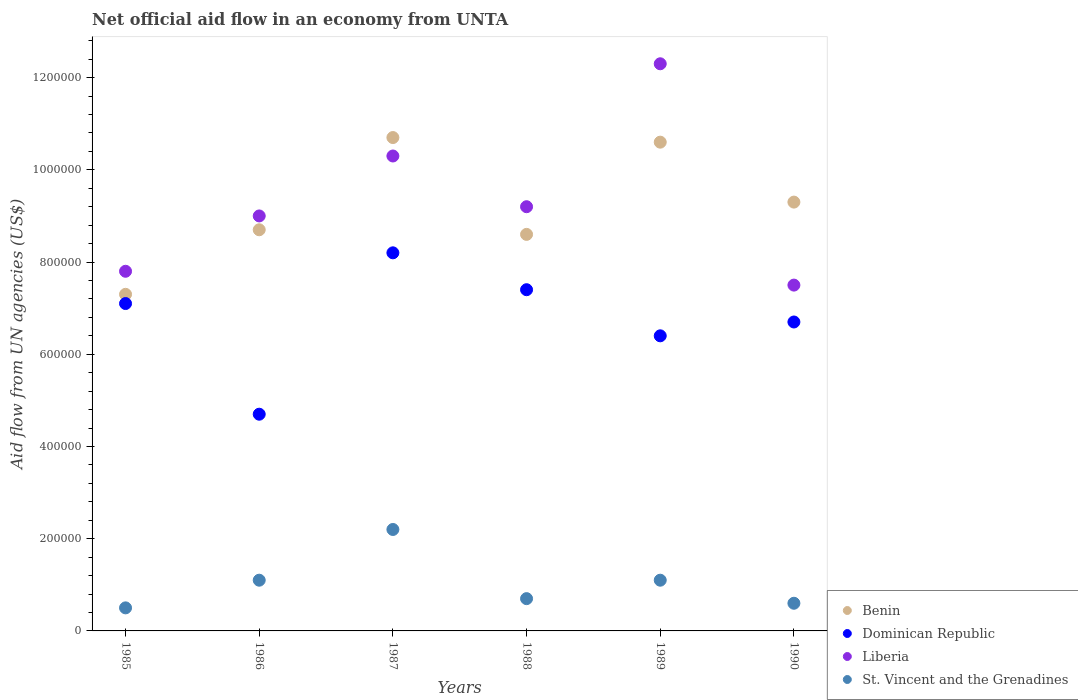How many different coloured dotlines are there?
Offer a very short reply. 4. What is the net official aid flow in Dominican Republic in 1988?
Ensure brevity in your answer.  7.40e+05. Across all years, what is the maximum net official aid flow in St. Vincent and the Grenadines?
Ensure brevity in your answer.  2.20e+05. Across all years, what is the minimum net official aid flow in Benin?
Your answer should be compact. 7.30e+05. In which year was the net official aid flow in St. Vincent and the Grenadines maximum?
Keep it short and to the point. 1987. In which year was the net official aid flow in Dominican Republic minimum?
Your answer should be compact. 1986. What is the total net official aid flow in Dominican Republic in the graph?
Make the answer very short. 4.05e+06. What is the difference between the net official aid flow in St. Vincent and the Grenadines in 1988 and that in 1990?
Your answer should be compact. 10000. What is the difference between the net official aid flow in Liberia in 1988 and the net official aid flow in St. Vincent and the Grenadines in 1986?
Offer a very short reply. 8.10e+05. What is the average net official aid flow in Benin per year?
Offer a very short reply. 9.20e+05. In how many years, is the net official aid flow in Dominican Republic greater than 520000 US$?
Your answer should be very brief. 5. What is the ratio of the net official aid flow in St. Vincent and the Grenadines in 1985 to that in 1988?
Offer a terse response. 0.71. Is the net official aid flow in St. Vincent and the Grenadines in 1985 less than that in 1989?
Offer a terse response. Yes. Is the difference between the net official aid flow in Benin in 1987 and 1989 greater than the difference between the net official aid flow in Liberia in 1987 and 1989?
Offer a very short reply. Yes. What is the difference between the highest and the second highest net official aid flow in Dominican Republic?
Keep it short and to the point. 8.00e+04. In how many years, is the net official aid flow in St. Vincent and the Grenadines greater than the average net official aid flow in St. Vincent and the Grenadines taken over all years?
Provide a short and direct response. 3. Is it the case that in every year, the sum of the net official aid flow in St. Vincent and the Grenadines and net official aid flow in Liberia  is greater than the net official aid flow in Dominican Republic?
Your response must be concise. Yes. What is the difference between two consecutive major ticks on the Y-axis?
Ensure brevity in your answer.  2.00e+05. Does the graph contain any zero values?
Give a very brief answer. No. What is the title of the graph?
Your response must be concise. Net official aid flow in an economy from UNTA. What is the label or title of the X-axis?
Give a very brief answer. Years. What is the label or title of the Y-axis?
Offer a terse response. Aid flow from UN agencies (US$). What is the Aid flow from UN agencies (US$) of Benin in 1985?
Provide a short and direct response. 7.30e+05. What is the Aid flow from UN agencies (US$) in Dominican Republic in 1985?
Provide a short and direct response. 7.10e+05. What is the Aid flow from UN agencies (US$) in Liberia in 1985?
Ensure brevity in your answer.  7.80e+05. What is the Aid flow from UN agencies (US$) of Benin in 1986?
Offer a very short reply. 8.70e+05. What is the Aid flow from UN agencies (US$) in Dominican Republic in 1986?
Make the answer very short. 4.70e+05. What is the Aid flow from UN agencies (US$) in Benin in 1987?
Give a very brief answer. 1.07e+06. What is the Aid flow from UN agencies (US$) in Dominican Republic in 1987?
Provide a succinct answer. 8.20e+05. What is the Aid flow from UN agencies (US$) of Liberia in 1987?
Offer a very short reply. 1.03e+06. What is the Aid flow from UN agencies (US$) of Benin in 1988?
Offer a terse response. 8.60e+05. What is the Aid flow from UN agencies (US$) in Dominican Republic in 1988?
Make the answer very short. 7.40e+05. What is the Aid flow from UN agencies (US$) in Liberia in 1988?
Your answer should be compact. 9.20e+05. What is the Aid flow from UN agencies (US$) in Benin in 1989?
Offer a very short reply. 1.06e+06. What is the Aid flow from UN agencies (US$) of Dominican Republic in 1989?
Ensure brevity in your answer.  6.40e+05. What is the Aid flow from UN agencies (US$) of Liberia in 1989?
Keep it short and to the point. 1.23e+06. What is the Aid flow from UN agencies (US$) of St. Vincent and the Grenadines in 1989?
Offer a terse response. 1.10e+05. What is the Aid flow from UN agencies (US$) of Benin in 1990?
Keep it short and to the point. 9.30e+05. What is the Aid flow from UN agencies (US$) in Dominican Republic in 1990?
Keep it short and to the point. 6.70e+05. What is the Aid flow from UN agencies (US$) of Liberia in 1990?
Provide a short and direct response. 7.50e+05. Across all years, what is the maximum Aid flow from UN agencies (US$) in Benin?
Your answer should be compact. 1.07e+06. Across all years, what is the maximum Aid flow from UN agencies (US$) in Dominican Republic?
Your response must be concise. 8.20e+05. Across all years, what is the maximum Aid flow from UN agencies (US$) of Liberia?
Your answer should be very brief. 1.23e+06. Across all years, what is the maximum Aid flow from UN agencies (US$) of St. Vincent and the Grenadines?
Your answer should be very brief. 2.20e+05. Across all years, what is the minimum Aid flow from UN agencies (US$) of Benin?
Give a very brief answer. 7.30e+05. Across all years, what is the minimum Aid flow from UN agencies (US$) of Dominican Republic?
Give a very brief answer. 4.70e+05. Across all years, what is the minimum Aid flow from UN agencies (US$) in Liberia?
Give a very brief answer. 7.50e+05. Across all years, what is the minimum Aid flow from UN agencies (US$) of St. Vincent and the Grenadines?
Offer a terse response. 5.00e+04. What is the total Aid flow from UN agencies (US$) in Benin in the graph?
Your answer should be compact. 5.52e+06. What is the total Aid flow from UN agencies (US$) in Dominican Republic in the graph?
Make the answer very short. 4.05e+06. What is the total Aid flow from UN agencies (US$) in Liberia in the graph?
Your response must be concise. 5.61e+06. What is the total Aid flow from UN agencies (US$) of St. Vincent and the Grenadines in the graph?
Give a very brief answer. 6.20e+05. What is the difference between the Aid flow from UN agencies (US$) in Dominican Republic in 1985 and that in 1986?
Your response must be concise. 2.40e+05. What is the difference between the Aid flow from UN agencies (US$) in Liberia in 1985 and that in 1986?
Provide a succinct answer. -1.20e+05. What is the difference between the Aid flow from UN agencies (US$) in St. Vincent and the Grenadines in 1985 and that in 1986?
Give a very brief answer. -6.00e+04. What is the difference between the Aid flow from UN agencies (US$) in Dominican Republic in 1985 and that in 1988?
Provide a succinct answer. -3.00e+04. What is the difference between the Aid flow from UN agencies (US$) of Liberia in 1985 and that in 1988?
Keep it short and to the point. -1.40e+05. What is the difference between the Aid flow from UN agencies (US$) in St. Vincent and the Grenadines in 1985 and that in 1988?
Provide a short and direct response. -2.00e+04. What is the difference between the Aid flow from UN agencies (US$) in Benin in 1985 and that in 1989?
Your answer should be compact. -3.30e+05. What is the difference between the Aid flow from UN agencies (US$) in Dominican Republic in 1985 and that in 1989?
Your answer should be very brief. 7.00e+04. What is the difference between the Aid flow from UN agencies (US$) in Liberia in 1985 and that in 1989?
Make the answer very short. -4.50e+05. What is the difference between the Aid flow from UN agencies (US$) in St. Vincent and the Grenadines in 1985 and that in 1989?
Make the answer very short. -6.00e+04. What is the difference between the Aid flow from UN agencies (US$) in Dominican Republic in 1985 and that in 1990?
Your response must be concise. 4.00e+04. What is the difference between the Aid flow from UN agencies (US$) in St. Vincent and the Grenadines in 1985 and that in 1990?
Give a very brief answer. -10000. What is the difference between the Aid flow from UN agencies (US$) of Dominican Republic in 1986 and that in 1987?
Your answer should be very brief. -3.50e+05. What is the difference between the Aid flow from UN agencies (US$) of Benin in 1986 and that in 1988?
Provide a succinct answer. 10000. What is the difference between the Aid flow from UN agencies (US$) in Dominican Republic in 1986 and that in 1988?
Your answer should be very brief. -2.70e+05. What is the difference between the Aid flow from UN agencies (US$) of St. Vincent and the Grenadines in 1986 and that in 1988?
Your response must be concise. 4.00e+04. What is the difference between the Aid flow from UN agencies (US$) in Benin in 1986 and that in 1989?
Provide a succinct answer. -1.90e+05. What is the difference between the Aid flow from UN agencies (US$) in Dominican Republic in 1986 and that in 1989?
Provide a succinct answer. -1.70e+05. What is the difference between the Aid flow from UN agencies (US$) of Liberia in 1986 and that in 1989?
Offer a very short reply. -3.30e+05. What is the difference between the Aid flow from UN agencies (US$) of St. Vincent and the Grenadines in 1986 and that in 1989?
Offer a very short reply. 0. What is the difference between the Aid flow from UN agencies (US$) of Dominican Republic in 1986 and that in 1990?
Give a very brief answer. -2.00e+05. What is the difference between the Aid flow from UN agencies (US$) of St. Vincent and the Grenadines in 1986 and that in 1990?
Your response must be concise. 5.00e+04. What is the difference between the Aid flow from UN agencies (US$) of Benin in 1987 and that in 1988?
Offer a terse response. 2.10e+05. What is the difference between the Aid flow from UN agencies (US$) of St. Vincent and the Grenadines in 1987 and that in 1988?
Offer a very short reply. 1.50e+05. What is the difference between the Aid flow from UN agencies (US$) of Benin in 1987 and that in 1989?
Your answer should be very brief. 10000. What is the difference between the Aid flow from UN agencies (US$) of Dominican Republic in 1987 and that in 1989?
Your answer should be very brief. 1.80e+05. What is the difference between the Aid flow from UN agencies (US$) of St. Vincent and the Grenadines in 1987 and that in 1989?
Your answer should be compact. 1.10e+05. What is the difference between the Aid flow from UN agencies (US$) in Liberia in 1987 and that in 1990?
Keep it short and to the point. 2.80e+05. What is the difference between the Aid flow from UN agencies (US$) in Benin in 1988 and that in 1989?
Your answer should be compact. -2.00e+05. What is the difference between the Aid flow from UN agencies (US$) in Liberia in 1988 and that in 1989?
Give a very brief answer. -3.10e+05. What is the difference between the Aid flow from UN agencies (US$) in St. Vincent and the Grenadines in 1988 and that in 1989?
Provide a succinct answer. -4.00e+04. What is the difference between the Aid flow from UN agencies (US$) in Benin in 1988 and that in 1990?
Provide a succinct answer. -7.00e+04. What is the difference between the Aid flow from UN agencies (US$) of Dominican Republic in 1988 and that in 1990?
Keep it short and to the point. 7.00e+04. What is the difference between the Aid flow from UN agencies (US$) in Liberia in 1988 and that in 1990?
Ensure brevity in your answer.  1.70e+05. What is the difference between the Aid flow from UN agencies (US$) of St. Vincent and the Grenadines in 1988 and that in 1990?
Offer a terse response. 10000. What is the difference between the Aid flow from UN agencies (US$) in Benin in 1989 and that in 1990?
Provide a short and direct response. 1.30e+05. What is the difference between the Aid flow from UN agencies (US$) of Dominican Republic in 1989 and that in 1990?
Make the answer very short. -3.00e+04. What is the difference between the Aid flow from UN agencies (US$) of Liberia in 1989 and that in 1990?
Your answer should be very brief. 4.80e+05. What is the difference between the Aid flow from UN agencies (US$) of Benin in 1985 and the Aid flow from UN agencies (US$) of Dominican Republic in 1986?
Your answer should be very brief. 2.60e+05. What is the difference between the Aid flow from UN agencies (US$) in Benin in 1985 and the Aid flow from UN agencies (US$) in St. Vincent and the Grenadines in 1986?
Offer a very short reply. 6.20e+05. What is the difference between the Aid flow from UN agencies (US$) in Dominican Republic in 1985 and the Aid flow from UN agencies (US$) in St. Vincent and the Grenadines in 1986?
Give a very brief answer. 6.00e+05. What is the difference between the Aid flow from UN agencies (US$) of Liberia in 1985 and the Aid flow from UN agencies (US$) of St. Vincent and the Grenadines in 1986?
Your response must be concise. 6.70e+05. What is the difference between the Aid flow from UN agencies (US$) in Benin in 1985 and the Aid flow from UN agencies (US$) in Dominican Republic in 1987?
Provide a succinct answer. -9.00e+04. What is the difference between the Aid flow from UN agencies (US$) in Benin in 1985 and the Aid flow from UN agencies (US$) in St. Vincent and the Grenadines in 1987?
Your answer should be compact. 5.10e+05. What is the difference between the Aid flow from UN agencies (US$) in Dominican Republic in 1985 and the Aid flow from UN agencies (US$) in Liberia in 1987?
Offer a very short reply. -3.20e+05. What is the difference between the Aid flow from UN agencies (US$) in Dominican Republic in 1985 and the Aid flow from UN agencies (US$) in St. Vincent and the Grenadines in 1987?
Your answer should be compact. 4.90e+05. What is the difference between the Aid flow from UN agencies (US$) of Liberia in 1985 and the Aid flow from UN agencies (US$) of St. Vincent and the Grenadines in 1987?
Offer a very short reply. 5.60e+05. What is the difference between the Aid flow from UN agencies (US$) of Benin in 1985 and the Aid flow from UN agencies (US$) of Liberia in 1988?
Your answer should be compact. -1.90e+05. What is the difference between the Aid flow from UN agencies (US$) of Dominican Republic in 1985 and the Aid flow from UN agencies (US$) of Liberia in 1988?
Give a very brief answer. -2.10e+05. What is the difference between the Aid flow from UN agencies (US$) in Dominican Republic in 1985 and the Aid flow from UN agencies (US$) in St. Vincent and the Grenadines in 1988?
Offer a terse response. 6.40e+05. What is the difference between the Aid flow from UN agencies (US$) of Liberia in 1985 and the Aid flow from UN agencies (US$) of St. Vincent and the Grenadines in 1988?
Your response must be concise. 7.10e+05. What is the difference between the Aid flow from UN agencies (US$) in Benin in 1985 and the Aid flow from UN agencies (US$) in Dominican Republic in 1989?
Your answer should be very brief. 9.00e+04. What is the difference between the Aid flow from UN agencies (US$) in Benin in 1985 and the Aid flow from UN agencies (US$) in Liberia in 1989?
Offer a very short reply. -5.00e+05. What is the difference between the Aid flow from UN agencies (US$) of Benin in 1985 and the Aid flow from UN agencies (US$) of St. Vincent and the Grenadines in 1989?
Provide a short and direct response. 6.20e+05. What is the difference between the Aid flow from UN agencies (US$) of Dominican Republic in 1985 and the Aid flow from UN agencies (US$) of Liberia in 1989?
Offer a very short reply. -5.20e+05. What is the difference between the Aid flow from UN agencies (US$) of Liberia in 1985 and the Aid flow from UN agencies (US$) of St. Vincent and the Grenadines in 1989?
Your response must be concise. 6.70e+05. What is the difference between the Aid flow from UN agencies (US$) in Benin in 1985 and the Aid flow from UN agencies (US$) in St. Vincent and the Grenadines in 1990?
Your answer should be very brief. 6.70e+05. What is the difference between the Aid flow from UN agencies (US$) in Dominican Republic in 1985 and the Aid flow from UN agencies (US$) in St. Vincent and the Grenadines in 1990?
Offer a very short reply. 6.50e+05. What is the difference between the Aid flow from UN agencies (US$) in Liberia in 1985 and the Aid flow from UN agencies (US$) in St. Vincent and the Grenadines in 1990?
Your answer should be compact. 7.20e+05. What is the difference between the Aid flow from UN agencies (US$) of Benin in 1986 and the Aid flow from UN agencies (US$) of Dominican Republic in 1987?
Make the answer very short. 5.00e+04. What is the difference between the Aid flow from UN agencies (US$) in Benin in 1986 and the Aid flow from UN agencies (US$) in Liberia in 1987?
Your answer should be very brief. -1.60e+05. What is the difference between the Aid flow from UN agencies (US$) in Benin in 1986 and the Aid flow from UN agencies (US$) in St. Vincent and the Grenadines in 1987?
Offer a very short reply. 6.50e+05. What is the difference between the Aid flow from UN agencies (US$) of Dominican Republic in 1986 and the Aid flow from UN agencies (US$) of Liberia in 1987?
Make the answer very short. -5.60e+05. What is the difference between the Aid flow from UN agencies (US$) in Liberia in 1986 and the Aid flow from UN agencies (US$) in St. Vincent and the Grenadines in 1987?
Your answer should be compact. 6.80e+05. What is the difference between the Aid flow from UN agencies (US$) of Benin in 1986 and the Aid flow from UN agencies (US$) of Dominican Republic in 1988?
Your answer should be compact. 1.30e+05. What is the difference between the Aid flow from UN agencies (US$) of Benin in 1986 and the Aid flow from UN agencies (US$) of Liberia in 1988?
Make the answer very short. -5.00e+04. What is the difference between the Aid flow from UN agencies (US$) of Benin in 1986 and the Aid flow from UN agencies (US$) of St. Vincent and the Grenadines in 1988?
Your answer should be very brief. 8.00e+05. What is the difference between the Aid flow from UN agencies (US$) of Dominican Republic in 1986 and the Aid flow from UN agencies (US$) of Liberia in 1988?
Make the answer very short. -4.50e+05. What is the difference between the Aid flow from UN agencies (US$) in Liberia in 1986 and the Aid flow from UN agencies (US$) in St. Vincent and the Grenadines in 1988?
Your answer should be compact. 8.30e+05. What is the difference between the Aid flow from UN agencies (US$) of Benin in 1986 and the Aid flow from UN agencies (US$) of Dominican Republic in 1989?
Provide a short and direct response. 2.30e+05. What is the difference between the Aid flow from UN agencies (US$) of Benin in 1986 and the Aid flow from UN agencies (US$) of Liberia in 1989?
Provide a succinct answer. -3.60e+05. What is the difference between the Aid flow from UN agencies (US$) in Benin in 1986 and the Aid flow from UN agencies (US$) in St. Vincent and the Grenadines in 1989?
Make the answer very short. 7.60e+05. What is the difference between the Aid flow from UN agencies (US$) in Dominican Republic in 1986 and the Aid flow from UN agencies (US$) in Liberia in 1989?
Give a very brief answer. -7.60e+05. What is the difference between the Aid flow from UN agencies (US$) of Dominican Republic in 1986 and the Aid flow from UN agencies (US$) of St. Vincent and the Grenadines in 1989?
Offer a very short reply. 3.60e+05. What is the difference between the Aid flow from UN agencies (US$) of Liberia in 1986 and the Aid flow from UN agencies (US$) of St. Vincent and the Grenadines in 1989?
Offer a very short reply. 7.90e+05. What is the difference between the Aid flow from UN agencies (US$) in Benin in 1986 and the Aid flow from UN agencies (US$) in St. Vincent and the Grenadines in 1990?
Your response must be concise. 8.10e+05. What is the difference between the Aid flow from UN agencies (US$) in Dominican Republic in 1986 and the Aid flow from UN agencies (US$) in Liberia in 1990?
Ensure brevity in your answer.  -2.80e+05. What is the difference between the Aid flow from UN agencies (US$) of Dominican Republic in 1986 and the Aid flow from UN agencies (US$) of St. Vincent and the Grenadines in 1990?
Give a very brief answer. 4.10e+05. What is the difference between the Aid flow from UN agencies (US$) in Liberia in 1986 and the Aid flow from UN agencies (US$) in St. Vincent and the Grenadines in 1990?
Your response must be concise. 8.40e+05. What is the difference between the Aid flow from UN agencies (US$) of Benin in 1987 and the Aid flow from UN agencies (US$) of Liberia in 1988?
Provide a short and direct response. 1.50e+05. What is the difference between the Aid flow from UN agencies (US$) of Dominican Republic in 1987 and the Aid flow from UN agencies (US$) of St. Vincent and the Grenadines in 1988?
Keep it short and to the point. 7.50e+05. What is the difference between the Aid flow from UN agencies (US$) in Liberia in 1987 and the Aid flow from UN agencies (US$) in St. Vincent and the Grenadines in 1988?
Ensure brevity in your answer.  9.60e+05. What is the difference between the Aid flow from UN agencies (US$) in Benin in 1987 and the Aid flow from UN agencies (US$) in Liberia in 1989?
Provide a short and direct response. -1.60e+05. What is the difference between the Aid flow from UN agencies (US$) of Benin in 1987 and the Aid flow from UN agencies (US$) of St. Vincent and the Grenadines in 1989?
Make the answer very short. 9.60e+05. What is the difference between the Aid flow from UN agencies (US$) in Dominican Republic in 1987 and the Aid flow from UN agencies (US$) in Liberia in 1989?
Provide a short and direct response. -4.10e+05. What is the difference between the Aid flow from UN agencies (US$) of Dominican Republic in 1987 and the Aid flow from UN agencies (US$) of St. Vincent and the Grenadines in 1989?
Offer a very short reply. 7.10e+05. What is the difference between the Aid flow from UN agencies (US$) of Liberia in 1987 and the Aid flow from UN agencies (US$) of St. Vincent and the Grenadines in 1989?
Offer a very short reply. 9.20e+05. What is the difference between the Aid flow from UN agencies (US$) in Benin in 1987 and the Aid flow from UN agencies (US$) in Dominican Republic in 1990?
Offer a terse response. 4.00e+05. What is the difference between the Aid flow from UN agencies (US$) of Benin in 1987 and the Aid flow from UN agencies (US$) of St. Vincent and the Grenadines in 1990?
Provide a short and direct response. 1.01e+06. What is the difference between the Aid flow from UN agencies (US$) in Dominican Republic in 1987 and the Aid flow from UN agencies (US$) in Liberia in 1990?
Give a very brief answer. 7.00e+04. What is the difference between the Aid flow from UN agencies (US$) in Dominican Republic in 1987 and the Aid flow from UN agencies (US$) in St. Vincent and the Grenadines in 1990?
Your response must be concise. 7.60e+05. What is the difference between the Aid flow from UN agencies (US$) of Liberia in 1987 and the Aid flow from UN agencies (US$) of St. Vincent and the Grenadines in 1990?
Your answer should be very brief. 9.70e+05. What is the difference between the Aid flow from UN agencies (US$) in Benin in 1988 and the Aid flow from UN agencies (US$) in Liberia in 1989?
Your answer should be compact. -3.70e+05. What is the difference between the Aid flow from UN agencies (US$) in Benin in 1988 and the Aid flow from UN agencies (US$) in St. Vincent and the Grenadines in 1989?
Your answer should be very brief. 7.50e+05. What is the difference between the Aid flow from UN agencies (US$) in Dominican Republic in 1988 and the Aid flow from UN agencies (US$) in Liberia in 1989?
Make the answer very short. -4.90e+05. What is the difference between the Aid flow from UN agencies (US$) of Dominican Republic in 1988 and the Aid flow from UN agencies (US$) of St. Vincent and the Grenadines in 1989?
Your answer should be very brief. 6.30e+05. What is the difference between the Aid flow from UN agencies (US$) in Liberia in 1988 and the Aid flow from UN agencies (US$) in St. Vincent and the Grenadines in 1989?
Give a very brief answer. 8.10e+05. What is the difference between the Aid flow from UN agencies (US$) in Benin in 1988 and the Aid flow from UN agencies (US$) in Liberia in 1990?
Make the answer very short. 1.10e+05. What is the difference between the Aid flow from UN agencies (US$) of Dominican Republic in 1988 and the Aid flow from UN agencies (US$) of St. Vincent and the Grenadines in 1990?
Provide a short and direct response. 6.80e+05. What is the difference between the Aid flow from UN agencies (US$) of Liberia in 1988 and the Aid flow from UN agencies (US$) of St. Vincent and the Grenadines in 1990?
Keep it short and to the point. 8.60e+05. What is the difference between the Aid flow from UN agencies (US$) in Benin in 1989 and the Aid flow from UN agencies (US$) in Liberia in 1990?
Your answer should be compact. 3.10e+05. What is the difference between the Aid flow from UN agencies (US$) of Dominican Republic in 1989 and the Aid flow from UN agencies (US$) of Liberia in 1990?
Your response must be concise. -1.10e+05. What is the difference between the Aid flow from UN agencies (US$) of Dominican Republic in 1989 and the Aid flow from UN agencies (US$) of St. Vincent and the Grenadines in 1990?
Ensure brevity in your answer.  5.80e+05. What is the difference between the Aid flow from UN agencies (US$) in Liberia in 1989 and the Aid flow from UN agencies (US$) in St. Vincent and the Grenadines in 1990?
Your response must be concise. 1.17e+06. What is the average Aid flow from UN agencies (US$) in Benin per year?
Ensure brevity in your answer.  9.20e+05. What is the average Aid flow from UN agencies (US$) of Dominican Republic per year?
Your answer should be compact. 6.75e+05. What is the average Aid flow from UN agencies (US$) of Liberia per year?
Your response must be concise. 9.35e+05. What is the average Aid flow from UN agencies (US$) of St. Vincent and the Grenadines per year?
Give a very brief answer. 1.03e+05. In the year 1985, what is the difference between the Aid flow from UN agencies (US$) of Benin and Aid flow from UN agencies (US$) of Dominican Republic?
Offer a very short reply. 2.00e+04. In the year 1985, what is the difference between the Aid flow from UN agencies (US$) of Benin and Aid flow from UN agencies (US$) of St. Vincent and the Grenadines?
Make the answer very short. 6.80e+05. In the year 1985, what is the difference between the Aid flow from UN agencies (US$) in Dominican Republic and Aid flow from UN agencies (US$) in St. Vincent and the Grenadines?
Your answer should be very brief. 6.60e+05. In the year 1985, what is the difference between the Aid flow from UN agencies (US$) of Liberia and Aid flow from UN agencies (US$) of St. Vincent and the Grenadines?
Make the answer very short. 7.30e+05. In the year 1986, what is the difference between the Aid flow from UN agencies (US$) in Benin and Aid flow from UN agencies (US$) in Dominican Republic?
Your answer should be compact. 4.00e+05. In the year 1986, what is the difference between the Aid flow from UN agencies (US$) of Benin and Aid flow from UN agencies (US$) of St. Vincent and the Grenadines?
Make the answer very short. 7.60e+05. In the year 1986, what is the difference between the Aid flow from UN agencies (US$) of Dominican Republic and Aid flow from UN agencies (US$) of Liberia?
Your answer should be very brief. -4.30e+05. In the year 1986, what is the difference between the Aid flow from UN agencies (US$) of Dominican Republic and Aid flow from UN agencies (US$) of St. Vincent and the Grenadines?
Give a very brief answer. 3.60e+05. In the year 1986, what is the difference between the Aid flow from UN agencies (US$) of Liberia and Aid flow from UN agencies (US$) of St. Vincent and the Grenadines?
Your answer should be compact. 7.90e+05. In the year 1987, what is the difference between the Aid flow from UN agencies (US$) of Benin and Aid flow from UN agencies (US$) of St. Vincent and the Grenadines?
Provide a succinct answer. 8.50e+05. In the year 1987, what is the difference between the Aid flow from UN agencies (US$) in Liberia and Aid flow from UN agencies (US$) in St. Vincent and the Grenadines?
Give a very brief answer. 8.10e+05. In the year 1988, what is the difference between the Aid flow from UN agencies (US$) of Benin and Aid flow from UN agencies (US$) of St. Vincent and the Grenadines?
Offer a very short reply. 7.90e+05. In the year 1988, what is the difference between the Aid flow from UN agencies (US$) of Dominican Republic and Aid flow from UN agencies (US$) of St. Vincent and the Grenadines?
Make the answer very short. 6.70e+05. In the year 1988, what is the difference between the Aid flow from UN agencies (US$) in Liberia and Aid flow from UN agencies (US$) in St. Vincent and the Grenadines?
Your response must be concise. 8.50e+05. In the year 1989, what is the difference between the Aid flow from UN agencies (US$) in Benin and Aid flow from UN agencies (US$) in St. Vincent and the Grenadines?
Your answer should be very brief. 9.50e+05. In the year 1989, what is the difference between the Aid flow from UN agencies (US$) in Dominican Republic and Aid flow from UN agencies (US$) in Liberia?
Your answer should be very brief. -5.90e+05. In the year 1989, what is the difference between the Aid flow from UN agencies (US$) of Dominican Republic and Aid flow from UN agencies (US$) of St. Vincent and the Grenadines?
Ensure brevity in your answer.  5.30e+05. In the year 1989, what is the difference between the Aid flow from UN agencies (US$) of Liberia and Aid flow from UN agencies (US$) of St. Vincent and the Grenadines?
Offer a very short reply. 1.12e+06. In the year 1990, what is the difference between the Aid flow from UN agencies (US$) in Benin and Aid flow from UN agencies (US$) in St. Vincent and the Grenadines?
Provide a short and direct response. 8.70e+05. In the year 1990, what is the difference between the Aid flow from UN agencies (US$) in Liberia and Aid flow from UN agencies (US$) in St. Vincent and the Grenadines?
Your answer should be compact. 6.90e+05. What is the ratio of the Aid flow from UN agencies (US$) of Benin in 1985 to that in 1986?
Give a very brief answer. 0.84. What is the ratio of the Aid flow from UN agencies (US$) in Dominican Republic in 1985 to that in 1986?
Provide a short and direct response. 1.51. What is the ratio of the Aid flow from UN agencies (US$) in Liberia in 1985 to that in 1986?
Your answer should be compact. 0.87. What is the ratio of the Aid flow from UN agencies (US$) of St. Vincent and the Grenadines in 1985 to that in 1986?
Offer a very short reply. 0.45. What is the ratio of the Aid flow from UN agencies (US$) of Benin in 1985 to that in 1987?
Your answer should be very brief. 0.68. What is the ratio of the Aid flow from UN agencies (US$) of Dominican Republic in 1985 to that in 1987?
Provide a succinct answer. 0.87. What is the ratio of the Aid flow from UN agencies (US$) in Liberia in 1985 to that in 1987?
Your answer should be compact. 0.76. What is the ratio of the Aid flow from UN agencies (US$) in St. Vincent and the Grenadines in 1985 to that in 1987?
Keep it short and to the point. 0.23. What is the ratio of the Aid flow from UN agencies (US$) in Benin in 1985 to that in 1988?
Give a very brief answer. 0.85. What is the ratio of the Aid flow from UN agencies (US$) in Dominican Republic in 1985 to that in 1988?
Ensure brevity in your answer.  0.96. What is the ratio of the Aid flow from UN agencies (US$) of Liberia in 1985 to that in 1988?
Offer a very short reply. 0.85. What is the ratio of the Aid flow from UN agencies (US$) in Benin in 1985 to that in 1989?
Your answer should be very brief. 0.69. What is the ratio of the Aid flow from UN agencies (US$) in Dominican Republic in 1985 to that in 1989?
Your response must be concise. 1.11. What is the ratio of the Aid flow from UN agencies (US$) in Liberia in 1985 to that in 1989?
Give a very brief answer. 0.63. What is the ratio of the Aid flow from UN agencies (US$) in St. Vincent and the Grenadines in 1985 to that in 1989?
Provide a succinct answer. 0.45. What is the ratio of the Aid flow from UN agencies (US$) of Benin in 1985 to that in 1990?
Keep it short and to the point. 0.78. What is the ratio of the Aid flow from UN agencies (US$) in Dominican Republic in 1985 to that in 1990?
Your answer should be very brief. 1.06. What is the ratio of the Aid flow from UN agencies (US$) of Benin in 1986 to that in 1987?
Make the answer very short. 0.81. What is the ratio of the Aid flow from UN agencies (US$) in Dominican Republic in 1986 to that in 1987?
Keep it short and to the point. 0.57. What is the ratio of the Aid flow from UN agencies (US$) of Liberia in 1986 to that in 1987?
Offer a terse response. 0.87. What is the ratio of the Aid flow from UN agencies (US$) of Benin in 1986 to that in 1988?
Your response must be concise. 1.01. What is the ratio of the Aid flow from UN agencies (US$) in Dominican Republic in 1986 to that in 1988?
Your answer should be compact. 0.64. What is the ratio of the Aid flow from UN agencies (US$) of Liberia in 1986 to that in 1988?
Offer a very short reply. 0.98. What is the ratio of the Aid flow from UN agencies (US$) of St. Vincent and the Grenadines in 1986 to that in 1988?
Make the answer very short. 1.57. What is the ratio of the Aid flow from UN agencies (US$) in Benin in 1986 to that in 1989?
Keep it short and to the point. 0.82. What is the ratio of the Aid flow from UN agencies (US$) in Dominican Republic in 1986 to that in 1989?
Provide a short and direct response. 0.73. What is the ratio of the Aid flow from UN agencies (US$) in Liberia in 1986 to that in 1989?
Offer a terse response. 0.73. What is the ratio of the Aid flow from UN agencies (US$) in Benin in 1986 to that in 1990?
Provide a short and direct response. 0.94. What is the ratio of the Aid flow from UN agencies (US$) of Dominican Republic in 1986 to that in 1990?
Make the answer very short. 0.7. What is the ratio of the Aid flow from UN agencies (US$) in St. Vincent and the Grenadines in 1986 to that in 1990?
Offer a very short reply. 1.83. What is the ratio of the Aid flow from UN agencies (US$) of Benin in 1987 to that in 1988?
Provide a succinct answer. 1.24. What is the ratio of the Aid flow from UN agencies (US$) of Dominican Republic in 1987 to that in 1988?
Give a very brief answer. 1.11. What is the ratio of the Aid flow from UN agencies (US$) in Liberia in 1987 to that in 1988?
Your response must be concise. 1.12. What is the ratio of the Aid flow from UN agencies (US$) of St. Vincent and the Grenadines in 1987 to that in 1988?
Provide a succinct answer. 3.14. What is the ratio of the Aid flow from UN agencies (US$) in Benin in 1987 to that in 1989?
Offer a terse response. 1.01. What is the ratio of the Aid flow from UN agencies (US$) of Dominican Republic in 1987 to that in 1989?
Your response must be concise. 1.28. What is the ratio of the Aid flow from UN agencies (US$) of Liberia in 1987 to that in 1989?
Give a very brief answer. 0.84. What is the ratio of the Aid flow from UN agencies (US$) of Benin in 1987 to that in 1990?
Your answer should be very brief. 1.15. What is the ratio of the Aid flow from UN agencies (US$) of Dominican Republic in 1987 to that in 1990?
Offer a terse response. 1.22. What is the ratio of the Aid flow from UN agencies (US$) of Liberia in 1987 to that in 1990?
Your answer should be compact. 1.37. What is the ratio of the Aid flow from UN agencies (US$) of St. Vincent and the Grenadines in 1987 to that in 1990?
Ensure brevity in your answer.  3.67. What is the ratio of the Aid flow from UN agencies (US$) in Benin in 1988 to that in 1989?
Provide a short and direct response. 0.81. What is the ratio of the Aid flow from UN agencies (US$) of Dominican Republic in 1988 to that in 1989?
Offer a very short reply. 1.16. What is the ratio of the Aid flow from UN agencies (US$) of Liberia in 1988 to that in 1989?
Ensure brevity in your answer.  0.75. What is the ratio of the Aid flow from UN agencies (US$) of St. Vincent and the Grenadines in 1988 to that in 1989?
Make the answer very short. 0.64. What is the ratio of the Aid flow from UN agencies (US$) of Benin in 1988 to that in 1990?
Make the answer very short. 0.92. What is the ratio of the Aid flow from UN agencies (US$) in Dominican Republic in 1988 to that in 1990?
Offer a terse response. 1.1. What is the ratio of the Aid flow from UN agencies (US$) of Liberia in 1988 to that in 1990?
Your answer should be compact. 1.23. What is the ratio of the Aid flow from UN agencies (US$) of Benin in 1989 to that in 1990?
Provide a short and direct response. 1.14. What is the ratio of the Aid flow from UN agencies (US$) in Dominican Republic in 1989 to that in 1990?
Offer a very short reply. 0.96. What is the ratio of the Aid flow from UN agencies (US$) of Liberia in 1989 to that in 1990?
Give a very brief answer. 1.64. What is the ratio of the Aid flow from UN agencies (US$) of St. Vincent and the Grenadines in 1989 to that in 1990?
Provide a short and direct response. 1.83. What is the difference between the highest and the second highest Aid flow from UN agencies (US$) of Dominican Republic?
Keep it short and to the point. 8.00e+04. What is the difference between the highest and the second highest Aid flow from UN agencies (US$) of Liberia?
Give a very brief answer. 2.00e+05. What is the difference between the highest and the lowest Aid flow from UN agencies (US$) in Benin?
Keep it short and to the point. 3.40e+05. What is the difference between the highest and the lowest Aid flow from UN agencies (US$) in Dominican Republic?
Ensure brevity in your answer.  3.50e+05. What is the difference between the highest and the lowest Aid flow from UN agencies (US$) in St. Vincent and the Grenadines?
Make the answer very short. 1.70e+05. 